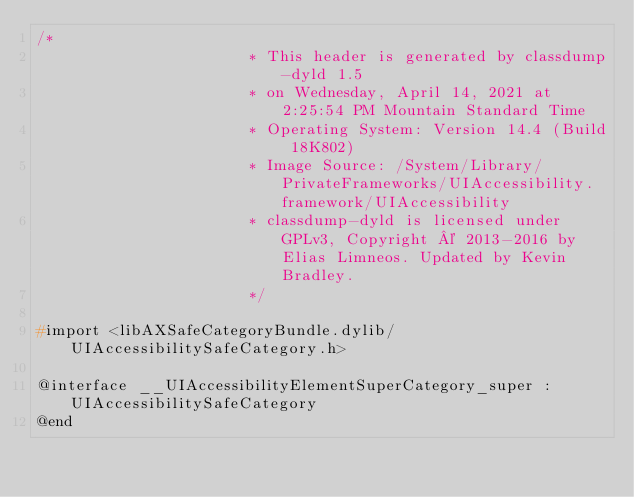Convert code to text. <code><loc_0><loc_0><loc_500><loc_500><_C_>/*
                       * This header is generated by classdump-dyld 1.5
                       * on Wednesday, April 14, 2021 at 2:25:54 PM Mountain Standard Time
                       * Operating System: Version 14.4 (Build 18K802)
                       * Image Source: /System/Library/PrivateFrameworks/UIAccessibility.framework/UIAccessibility
                       * classdump-dyld is licensed under GPLv3, Copyright © 2013-2016 by Elias Limneos. Updated by Kevin Bradley.
                       */

#import <libAXSafeCategoryBundle.dylib/UIAccessibilitySafeCategory.h>

@interface __UIAccessibilityElementSuperCategory_super : UIAccessibilitySafeCategory
@end

</code> 